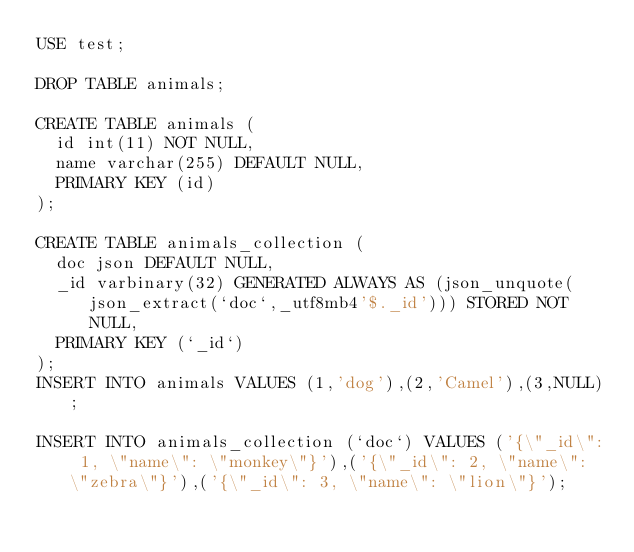<code> <loc_0><loc_0><loc_500><loc_500><_SQL_>USE test;

DROP TABLE animals;

CREATE TABLE animals (
  id int(11) NOT NULL,
  name varchar(255) DEFAULT NULL,
  PRIMARY KEY (id)
);

CREATE TABLE animals_collection (
  doc json DEFAULT NULL,
  _id varbinary(32) GENERATED ALWAYS AS (json_unquote(json_extract(`doc`,_utf8mb4'$._id'))) STORED NOT NULL,
  PRIMARY KEY (`_id`)
);
INSERT INTO animals VALUES (1,'dog'),(2,'Camel'),(3,NULL);

INSERT INTO animals_collection (`doc`) VALUES ('{\"_id\": 1, \"name\": \"monkey\"}'),('{\"_id\": 2, \"name\": \"zebra\"}'),('{\"_id\": 3, \"name\": \"lion\"}');
</code> 